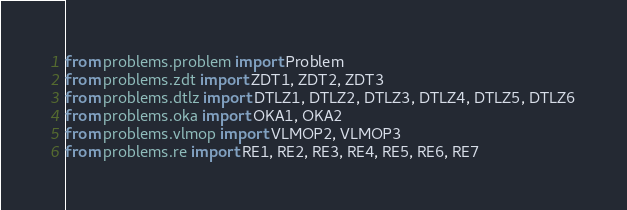<code> <loc_0><loc_0><loc_500><loc_500><_Python_>from problems.problem import Problem
from problems.zdt import ZDT1, ZDT2, ZDT3
from problems.dtlz import DTLZ1, DTLZ2, DTLZ3, DTLZ4, DTLZ5, DTLZ6
from problems.oka import OKA1, OKA2
from problems.vlmop import VLMOP2, VLMOP3
from problems.re import RE1, RE2, RE3, RE4, RE5, RE6, RE7</code> 